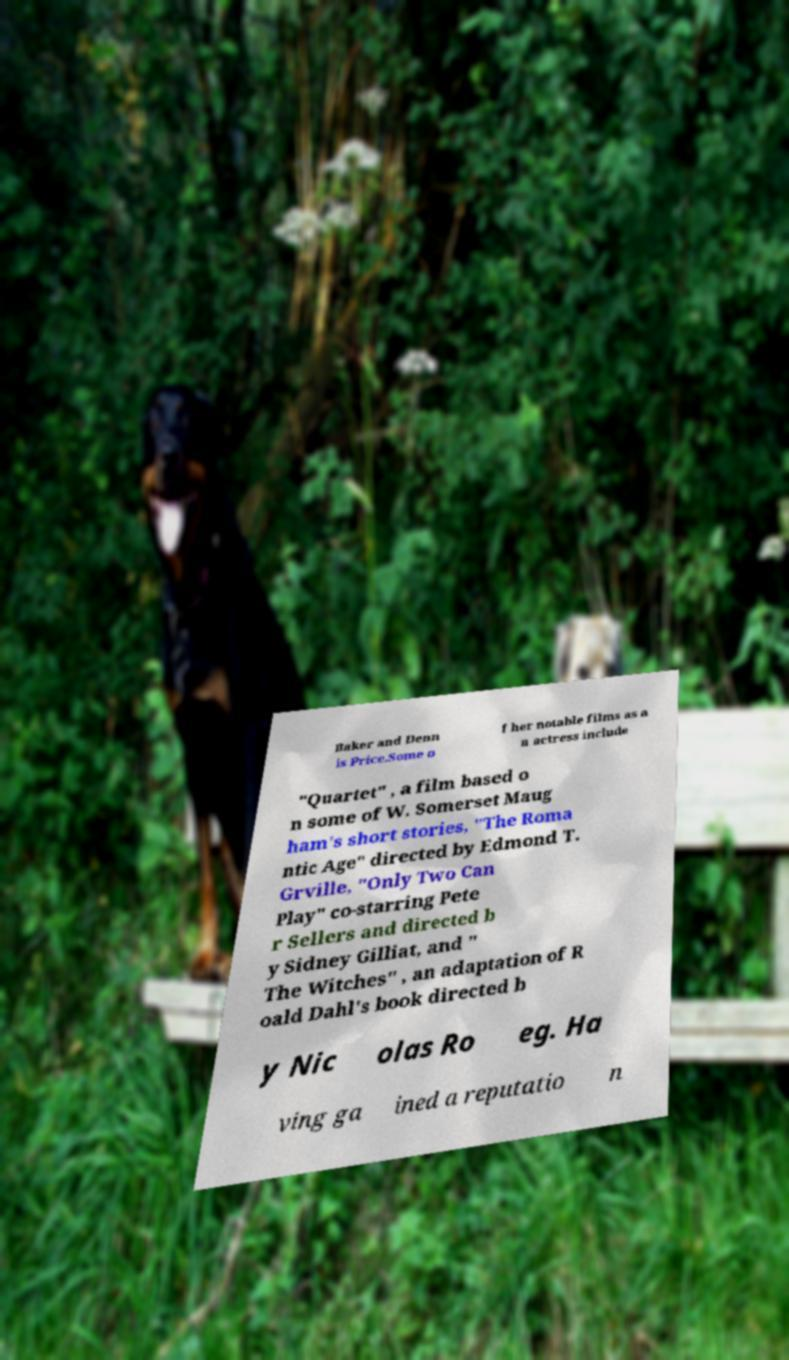Please identify and transcribe the text found in this image. Baker and Denn is Price.Some o f her notable films as a n actress include "Quartet" , a film based o n some of W. Somerset Maug ham's short stories, "The Roma ntic Age" directed by Edmond T. Grville, "Only Two Can Play" co-starring Pete r Sellers and directed b y Sidney Gilliat, and " The Witches" , an adaptation of R oald Dahl's book directed b y Nic olas Ro eg. Ha ving ga ined a reputatio n 